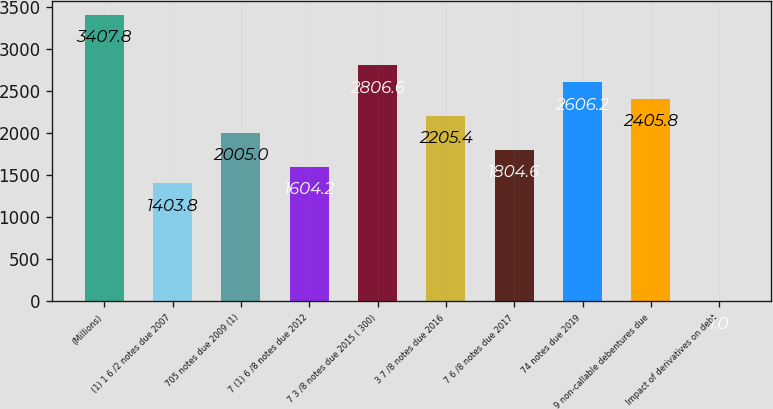Convert chart. <chart><loc_0><loc_0><loc_500><loc_500><bar_chart><fcel>(Millions)<fcel>(1) 1 6 /2 notes due 2007<fcel>705 notes due 2009 (1)<fcel>7 (1) 6 /8 notes due 2012<fcel>7 3 /8 notes due 2015 ( 300)<fcel>3 7 /8 notes due 2016<fcel>7 6 /8 notes due 2017<fcel>74 notes due 2019<fcel>9 non-callable debentures due<fcel>Impact of derivatives on debt<nl><fcel>3407.8<fcel>1403.8<fcel>2005<fcel>1604.2<fcel>2806.6<fcel>2205.4<fcel>1804.6<fcel>2606.2<fcel>2405.8<fcel>1<nl></chart> 